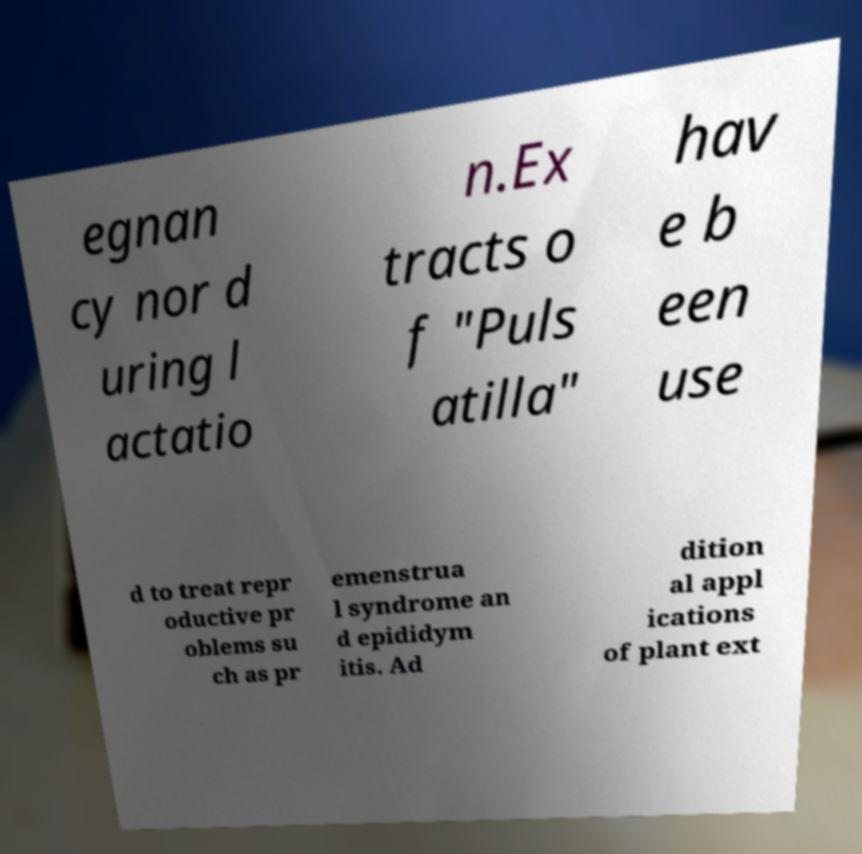What messages or text are displayed in this image? I need them in a readable, typed format. egnan cy nor d uring l actatio n.Ex tracts o f "Puls atilla" hav e b een use d to treat repr oductive pr oblems su ch as pr emenstrua l syndrome an d epididym itis. Ad dition al appl ications of plant ext 